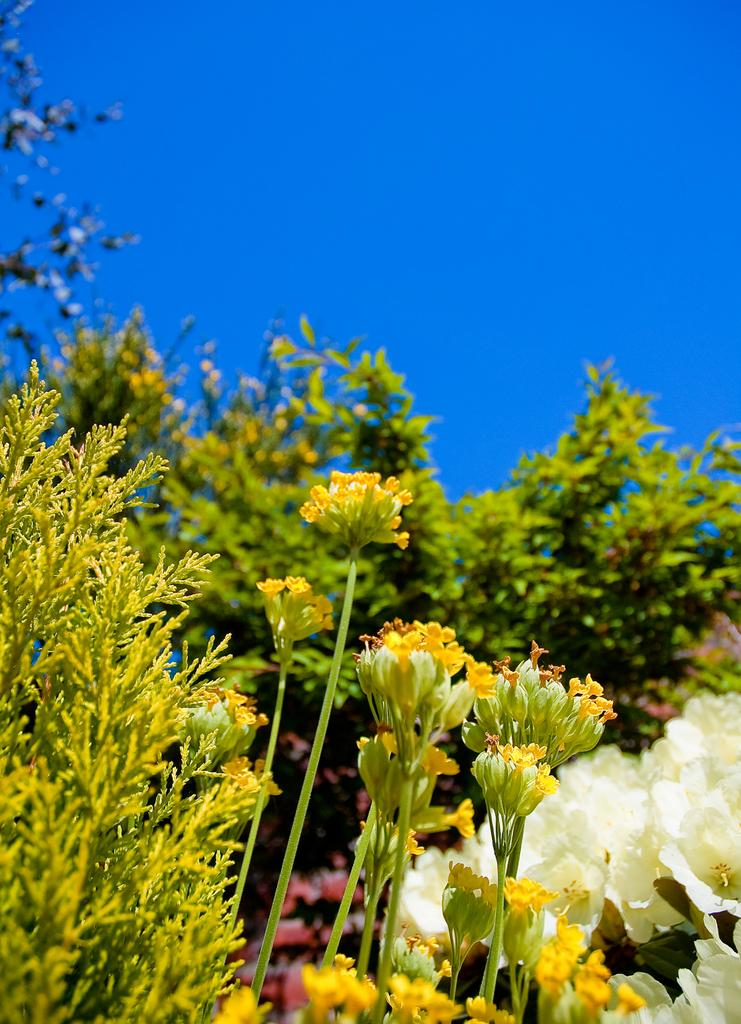What types of vegetation can be seen in the front of the image? There are plants and flowers in the front of the image. What can be seen in the background of the image? There is a tree in the background of the image. What is visible at the top of the image? The sky is visible at the top of the image. What type of calculator can be seen on the tree in the image? There is no calculator present on the tree in the image. What kind of horn is visible on the plants in the front of the image? There are no horns present on the plants in the front of the image. 